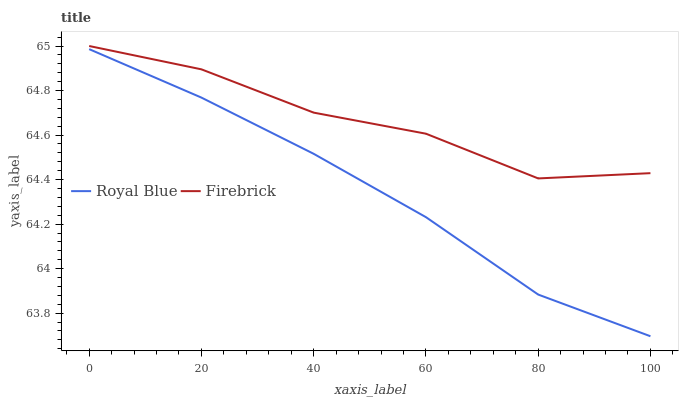Does Royal Blue have the minimum area under the curve?
Answer yes or no. Yes. Does Firebrick have the maximum area under the curve?
Answer yes or no. Yes. Does Firebrick have the minimum area under the curve?
Answer yes or no. No. Is Royal Blue the smoothest?
Answer yes or no. Yes. Is Firebrick the roughest?
Answer yes or no. Yes. Is Firebrick the smoothest?
Answer yes or no. No. Does Royal Blue have the lowest value?
Answer yes or no. Yes. Does Firebrick have the lowest value?
Answer yes or no. No. Does Firebrick have the highest value?
Answer yes or no. Yes. Is Royal Blue less than Firebrick?
Answer yes or no. Yes. Is Firebrick greater than Royal Blue?
Answer yes or no. Yes. Does Royal Blue intersect Firebrick?
Answer yes or no. No. 